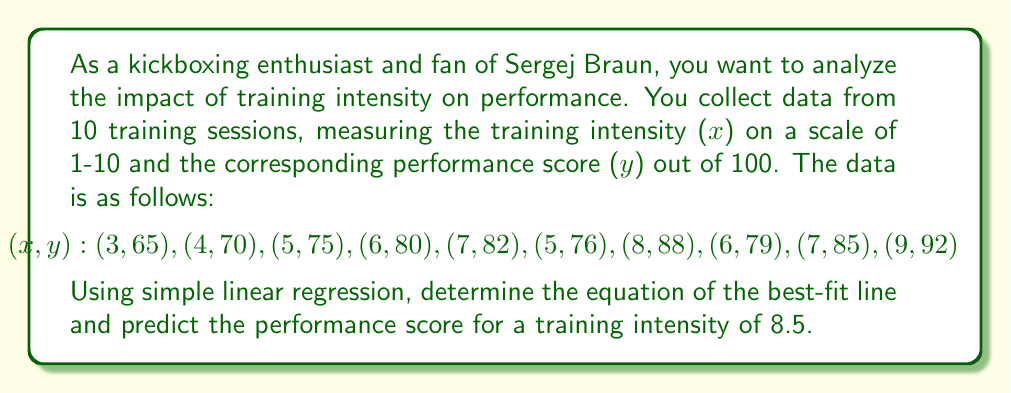Can you solve this math problem? To solve this problem, we'll use simple linear regression to find the best-fit line equation $y = mx + b$, where $m$ is the slope and $b$ is the y-intercept.

Step 1: Calculate the means of x and y
$$\bar{x} = \frac{3 + 4 + 5 + 6 + 7 + 5 + 8 + 6 + 7 + 9}{10} = 6$$
$$\bar{y} = \frac{65 + 70 + 75 + 80 + 82 + 76 + 88 + 79 + 85 + 92}{10} = 79.2$$

Step 2: Calculate the slope (m)
$$m = \frac{\sum(x_i - \bar{x})(y_i - \bar{y})}{\sum(x_i - \bar{x})^2}$$

$$\sum(x_i - \bar{x})(y_i - \bar{y}) = 176.2$$
$$\sum(x_i - \bar{x})^2 = 36$$

$$m = \frac{176.2}{36} = 4.8944$$

Step 3: Calculate the y-intercept (b)
$$b = \bar{y} - m\bar{x} = 79.2 - 4.8944 \cdot 6 = 49.8336$$

Step 4: Write the equation of the best-fit line
$$y = 4.8944x + 49.8336$$

Step 5: Predict the performance score for a training intensity of 8.5
$$y = 4.8944 \cdot 8.5 + 49.8336 = 91.4360$$

Therefore, the predicted performance score for a training intensity of 8.5 is approximately 91.44.
Answer: The equation of the best-fit line is $y = 4.8944x + 49.8336$, and the predicted performance score for a training intensity of 8.5 is 91.44. 